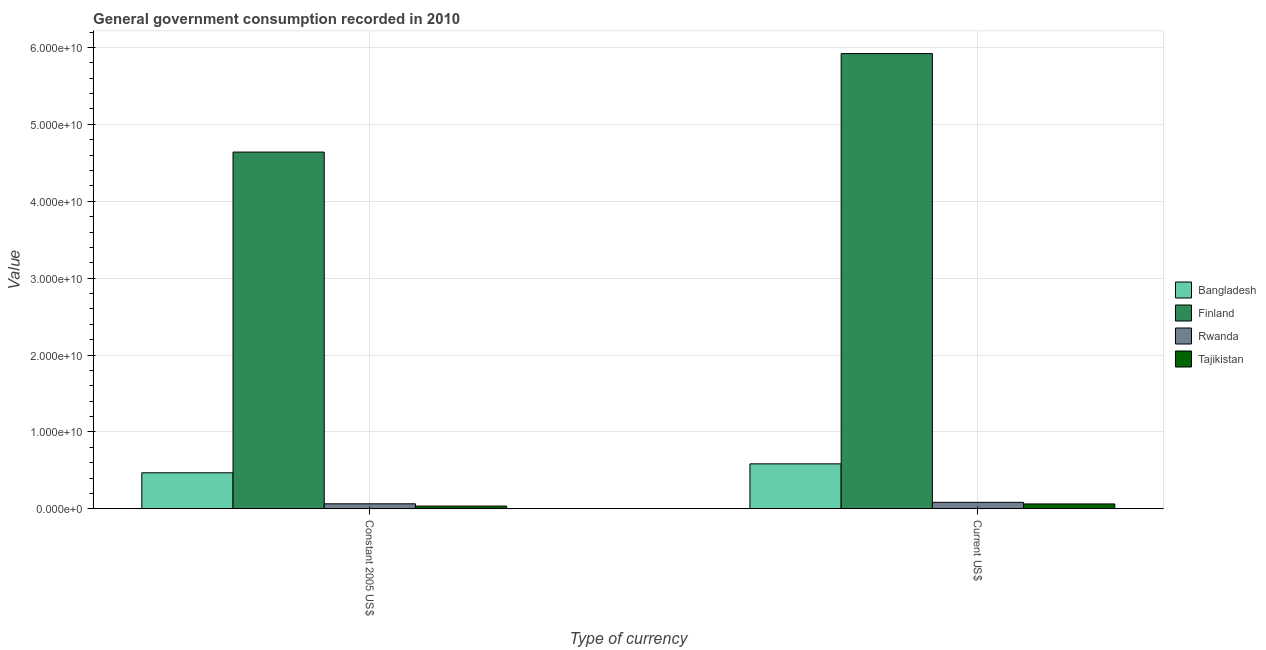How many bars are there on the 2nd tick from the left?
Offer a terse response. 4. How many bars are there on the 2nd tick from the right?
Offer a very short reply. 4. What is the label of the 2nd group of bars from the left?
Offer a terse response. Current US$. What is the value consumed in constant 2005 us$ in Finland?
Your response must be concise. 4.64e+1. Across all countries, what is the maximum value consumed in current us$?
Provide a succinct answer. 5.92e+1. Across all countries, what is the minimum value consumed in constant 2005 us$?
Provide a short and direct response. 3.58e+08. In which country was the value consumed in constant 2005 us$ maximum?
Your answer should be very brief. Finland. In which country was the value consumed in constant 2005 us$ minimum?
Offer a very short reply. Tajikistan. What is the total value consumed in constant 2005 us$ in the graph?
Ensure brevity in your answer.  5.21e+1. What is the difference between the value consumed in constant 2005 us$ in Finland and that in Tajikistan?
Make the answer very short. 4.60e+1. What is the difference between the value consumed in constant 2005 us$ in Rwanda and the value consumed in current us$ in Finland?
Ensure brevity in your answer.  -5.86e+1. What is the average value consumed in current us$ per country?
Provide a succinct answer. 1.66e+1. What is the difference between the value consumed in current us$ and value consumed in constant 2005 us$ in Bangladesh?
Offer a terse response. 1.16e+09. In how many countries, is the value consumed in constant 2005 us$ greater than 36000000000 ?
Make the answer very short. 1. What is the ratio of the value consumed in constant 2005 us$ in Rwanda to that in Bangladesh?
Provide a succinct answer. 0.14. What does the 3rd bar from the left in Current US$ represents?
Offer a very short reply. Rwanda. What does the 1st bar from the right in Current US$ represents?
Provide a succinct answer. Tajikistan. How many bars are there?
Make the answer very short. 8. Are all the bars in the graph horizontal?
Offer a terse response. No. Are the values on the major ticks of Y-axis written in scientific E-notation?
Make the answer very short. Yes. Does the graph contain any zero values?
Keep it short and to the point. No. How are the legend labels stacked?
Your answer should be compact. Vertical. What is the title of the graph?
Provide a short and direct response. General government consumption recorded in 2010. What is the label or title of the X-axis?
Your answer should be very brief. Type of currency. What is the label or title of the Y-axis?
Provide a short and direct response. Value. What is the Value of Bangladesh in Constant 2005 US$?
Your answer should be compact. 4.69e+09. What is the Value of Finland in Constant 2005 US$?
Ensure brevity in your answer.  4.64e+1. What is the Value of Rwanda in Constant 2005 US$?
Give a very brief answer. 6.55e+08. What is the Value in Tajikistan in Constant 2005 US$?
Give a very brief answer. 3.58e+08. What is the Value in Bangladesh in Current US$?
Your answer should be compact. 5.85e+09. What is the Value of Finland in Current US$?
Offer a very short reply. 5.92e+1. What is the Value of Rwanda in Current US$?
Provide a succinct answer. 8.47e+08. What is the Value of Tajikistan in Current US$?
Provide a short and direct response. 6.39e+08. Across all Type of currency, what is the maximum Value in Bangladesh?
Offer a terse response. 5.85e+09. Across all Type of currency, what is the maximum Value in Finland?
Offer a very short reply. 5.92e+1. Across all Type of currency, what is the maximum Value of Rwanda?
Provide a succinct answer. 8.47e+08. Across all Type of currency, what is the maximum Value in Tajikistan?
Give a very brief answer. 6.39e+08. Across all Type of currency, what is the minimum Value in Bangladesh?
Offer a terse response. 4.69e+09. Across all Type of currency, what is the minimum Value in Finland?
Make the answer very short. 4.64e+1. Across all Type of currency, what is the minimum Value of Rwanda?
Offer a terse response. 6.55e+08. Across all Type of currency, what is the minimum Value in Tajikistan?
Keep it short and to the point. 3.58e+08. What is the total Value in Bangladesh in the graph?
Offer a very short reply. 1.05e+1. What is the total Value of Finland in the graph?
Your answer should be compact. 1.06e+11. What is the total Value in Rwanda in the graph?
Give a very brief answer. 1.50e+09. What is the total Value of Tajikistan in the graph?
Provide a short and direct response. 9.97e+08. What is the difference between the Value in Bangladesh in Constant 2005 US$ and that in Current US$?
Provide a short and direct response. -1.16e+09. What is the difference between the Value in Finland in Constant 2005 US$ and that in Current US$?
Provide a short and direct response. -1.28e+1. What is the difference between the Value of Rwanda in Constant 2005 US$ and that in Current US$?
Your answer should be very brief. -1.92e+08. What is the difference between the Value of Tajikistan in Constant 2005 US$ and that in Current US$?
Give a very brief answer. -2.81e+08. What is the difference between the Value in Bangladesh in Constant 2005 US$ and the Value in Finland in Current US$?
Offer a very short reply. -5.45e+1. What is the difference between the Value of Bangladesh in Constant 2005 US$ and the Value of Rwanda in Current US$?
Provide a succinct answer. 3.84e+09. What is the difference between the Value of Bangladesh in Constant 2005 US$ and the Value of Tajikistan in Current US$?
Make the answer very short. 4.05e+09. What is the difference between the Value of Finland in Constant 2005 US$ and the Value of Rwanda in Current US$?
Make the answer very short. 4.56e+1. What is the difference between the Value in Finland in Constant 2005 US$ and the Value in Tajikistan in Current US$?
Keep it short and to the point. 4.58e+1. What is the difference between the Value of Rwanda in Constant 2005 US$ and the Value of Tajikistan in Current US$?
Offer a very short reply. 1.56e+07. What is the average Value in Bangladesh per Type of currency?
Your response must be concise. 5.27e+09. What is the average Value of Finland per Type of currency?
Provide a succinct answer. 5.28e+1. What is the average Value in Rwanda per Type of currency?
Keep it short and to the point. 7.51e+08. What is the average Value of Tajikistan per Type of currency?
Provide a succinct answer. 4.99e+08. What is the difference between the Value of Bangladesh and Value of Finland in Constant 2005 US$?
Give a very brief answer. -4.17e+1. What is the difference between the Value of Bangladesh and Value of Rwanda in Constant 2005 US$?
Keep it short and to the point. 4.03e+09. What is the difference between the Value of Bangladesh and Value of Tajikistan in Constant 2005 US$?
Your response must be concise. 4.33e+09. What is the difference between the Value in Finland and Value in Rwanda in Constant 2005 US$?
Offer a very short reply. 4.57e+1. What is the difference between the Value in Finland and Value in Tajikistan in Constant 2005 US$?
Your response must be concise. 4.60e+1. What is the difference between the Value in Rwanda and Value in Tajikistan in Constant 2005 US$?
Ensure brevity in your answer.  2.96e+08. What is the difference between the Value in Bangladesh and Value in Finland in Current US$?
Provide a succinct answer. -5.34e+1. What is the difference between the Value in Bangladesh and Value in Rwanda in Current US$?
Keep it short and to the point. 5.00e+09. What is the difference between the Value of Bangladesh and Value of Tajikistan in Current US$?
Make the answer very short. 5.21e+09. What is the difference between the Value in Finland and Value in Rwanda in Current US$?
Keep it short and to the point. 5.84e+1. What is the difference between the Value of Finland and Value of Tajikistan in Current US$?
Offer a very short reply. 5.86e+1. What is the difference between the Value of Rwanda and Value of Tajikistan in Current US$?
Make the answer very short. 2.08e+08. What is the ratio of the Value in Bangladesh in Constant 2005 US$ to that in Current US$?
Offer a very short reply. 0.8. What is the ratio of the Value in Finland in Constant 2005 US$ to that in Current US$?
Offer a very short reply. 0.78. What is the ratio of the Value of Rwanda in Constant 2005 US$ to that in Current US$?
Your response must be concise. 0.77. What is the ratio of the Value of Tajikistan in Constant 2005 US$ to that in Current US$?
Your answer should be very brief. 0.56. What is the difference between the highest and the second highest Value of Bangladesh?
Give a very brief answer. 1.16e+09. What is the difference between the highest and the second highest Value in Finland?
Offer a terse response. 1.28e+1. What is the difference between the highest and the second highest Value in Rwanda?
Your response must be concise. 1.92e+08. What is the difference between the highest and the second highest Value of Tajikistan?
Your answer should be compact. 2.81e+08. What is the difference between the highest and the lowest Value of Bangladesh?
Make the answer very short. 1.16e+09. What is the difference between the highest and the lowest Value of Finland?
Your response must be concise. 1.28e+1. What is the difference between the highest and the lowest Value in Rwanda?
Provide a short and direct response. 1.92e+08. What is the difference between the highest and the lowest Value of Tajikistan?
Keep it short and to the point. 2.81e+08. 